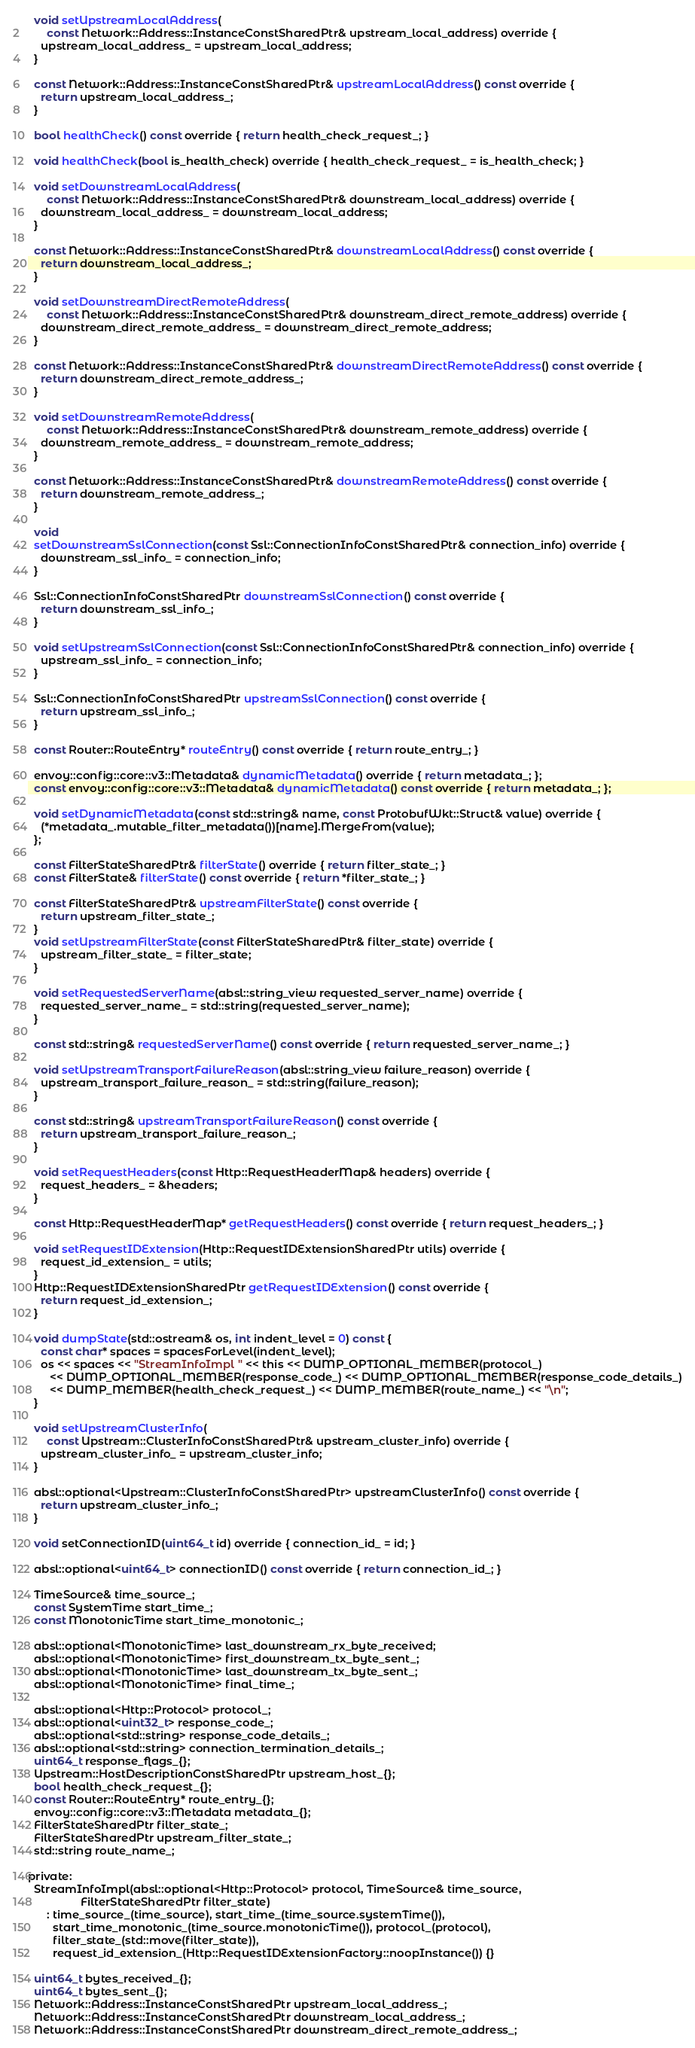<code> <loc_0><loc_0><loc_500><loc_500><_C_>
  void setUpstreamLocalAddress(
      const Network::Address::InstanceConstSharedPtr& upstream_local_address) override {
    upstream_local_address_ = upstream_local_address;
  }

  const Network::Address::InstanceConstSharedPtr& upstreamLocalAddress() const override {
    return upstream_local_address_;
  }

  bool healthCheck() const override { return health_check_request_; }

  void healthCheck(bool is_health_check) override { health_check_request_ = is_health_check; }

  void setDownstreamLocalAddress(
      const Network::Address::InstanceConstSharedPtr& downstream_local_address) override {
    downstream_local_address_ = downstream_local_address;
  }

  const Network::Address::InstanceConstSharedPtr& downstreamLocalAddress() const override {
    return downstream_local_address_;
  }

  void setDownstreamDirectRemoteAddress(
      const Network::Address::InstanceConstSharedPtr& downstream_direct_remote_address) override {
    downstream_direct_remote_address_ = downstream_direct_remote_address;
  }

  const Network::Address::InstanceConstSharedPtr& downstreamDirectRemoteAddress() const override {
    return downstream_direct_remote_address_;
  }

  void setDownstreamRemoteAddress(
      const Network::Address::InstanceConstSharedPtr& downstream_remote_address) override {
    downstream_remote_address_ = downstream_remote_address;
  }

  const Network::Address::InstanceConstSharedPtr& downstreamRemoteAddress() const override {
    return downstream_remote_address_;
  }

  void
  setDownstreamSslConnection(const Ssl::ConnectionInfoConstSharedPtr& connection_info) override {
    downstream_ssl_info_ = connection_info;
  }

  Ssl::ConnectionInfoConstSharedPtr downstreamSslConnection() const override {
    return downstream_ssl_info_;
  }

  void setUpstreamSslConnection(const Ssl::ConnectionInfoConstSharedPtr& connection_info) override {
    upstream_ssl_info_ = connection_info;
  }

  Ssl::ConnectionInfoConstSharedPtr upstreamSslConnection() const override {
    return upstream_ssl_info_;
  }

  const Router::RouteEntry* routeEntry() const override { return route_entry_; }

  envoy::config::core::v3::Metadata& dynamicMetadata() override { return metadata_; };
  const envoy::config::core::v3::Metadata& dynamicMetadata() const override { return metadata_; };

  void setDynamicMetadata(const std::string& name, const ProtobufWkt::Struct& value) override {
    (*metadata_.mutable_filter_metadata())[name].MergeFrom(value);
  };

  const FilterStateSharedPtr& filterState() override { return filter_state_; }
  const FilterState& filterState() const override { return *filter_state_; }

  const FilterStateSharedPtr& upstreamFilterState() const override {
    return upstream_filter_state_;
  }
  void setUpstreamFilterState(const FilterStateSharedPtr& filter_state) override {
    upstream_filter_state_ = filter_state;
  }

  void setRequestedServerName(absl::string_view requested_server_name) override {
    requested_server_name_ = std::string(requested_server_name);
  }

  const std::string& requestedServerName() const override { return requested_server_name_; }

  void setUpstreamTransportFailureReason(absl::string_view failure_reason) override {
    upstream_transport_failure_reason_ = std::string(failure_reason);
  }

  const std::string& upstreamTransportFailureReason() const override {
    return upstream_transport_failure_reason_;
  }

  void setRequestHeaders(const Http::RequestHeaderMap& headers) override {
    request_headers_ = &headers;
  }

  const Http::RequestHeaderMap* getRequestHeaders() const override { return request_headers_; }

  void setRequestIDExtension(Http::RequestIDExtensionSharedPtr utils) override {
    request_id_extension_ = utils;
  }
  Http::RequestIDExtensionSharedPtr getRequestIDExtension() const override {
    return request_id_extension_;
  }

  void dumpState(std::ostream& os, int indent_level = 0) const {
    const char* spaces = spacesForLevel(indent_level);
    os << spaces << "StreamInfoImpl " << this << DUMP_OPTIONAL_MEMBER(protocol_)
       << DUMP_OPTIONAL_MEMBER(response_code_) << DUMP_OPTIONAL_MEMBER(response_code_details_)
       << DUMP_MEMBER(health_check_request_) << DUMP_MEMBER(route_name_) << "\n";
  }

  void setUpstreamClusterInfo(
      const Upstream::ClusterInfoConstSharedPtr& upstream_cluster_info) override {
    upstream_cluster_info_ = upstream_cluster_info;
  }

  absl::optional<Upstream::ClusterInfoConstSharedPtr> upstreamClusterInfo() const override {
    return upstream_cluster_info_;
  }

  void setConnectionID(uint64_t id) override { connection_id_ = id; }

  absl::optional<uint64_t> connectionID() const override { return connection_id_; }

  TimeSource& time_source_;
  const SystemTime start_time_;
  const MonotonicTime start_time_monotonic_;

  absl::optional<MonotonicTime> last_downstream_rx_byte_received;
  absl::optional<MonotonicTime> first_downstream_tx_byte_sent_;
  absl::optional<MonotonicTime> last_downstream_tx_byte_sent_;
  absl::optional<MonotonicTime> final_time_;

  absl::optional<Http::Protocol> protocol_;
  absl::optional<uint32_t> response_code_;
  absl::optional<std::string> response_code_details_;
  absl::optional<std::string> connection_termination_details_;
  uint64_t response_flags_{};
  Upstream::HostDescriptionConstSharedPtr upstream_host_{};
  bool health_check_request_{};
  const Router::RouteEntry* route_entry_{};
  envoy::config::core::v3::Metadata metadata_{};
  FilterStateSharedPtr filter_state_;
  FilterStateSharedPtr upstream_filter_state_;
  std::string route_name_;

private:
  StreamInfoImpl(absl::optional<Http::Protocol> protocol, TimeSource& time_source,
                 FilterStateSharedPtr filter_state)
      : time_source_(time_source), start_time_(time_source.systemTime()),
        start_time_monotonic_(time_source.monotonicTime()), protocol_(protocol),
        filter_state_(std::move(filter_state)),
        request_id_extension_(Http::RequestIDExtensionFactory::noopInstance()) {}

  uint64_t bytes_received_{};
  uint64_t bytes_sent_{};
  Network::Address::InstanceConstSharedPtr upstream_local_address_;
  Network::Address::InstanceConstSharedPtr downstream_local_address_;
  Network::Address::InstanceConstSharedPtr downstream_direct_remote_address_;</code> 